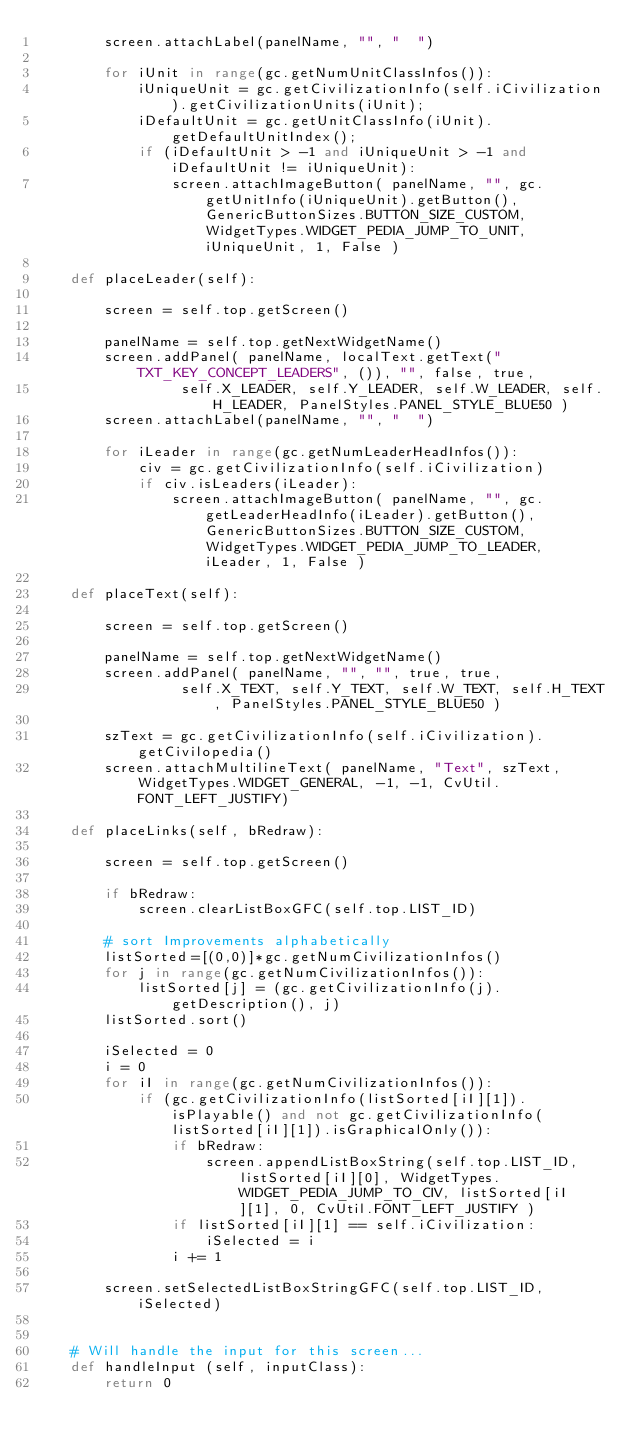Convert code to text. <code><loc_0><loc_0><loc_500><loc_500><_Python_>		screen.attachLabel(panelName, "", "  ")
					
		for iUnit in range(gc.getNumUnitClassInfos()):
			iUniqueUnit = gc.getCivilizationInfo(self.iCivilization).getCivilizationUnits(iUnit);
			iDefaultUnit = gc.getUnitClassInfo(iUnit).getDefaultUnitIndex();
			if (iDefaultUnit > -1 and iUniqueUnit > -1 and iDefaultUnit != iUniqueUnit):
				screen.attachImageButton( panelName, "", gc.getUnitInfo(iUniqueUnit).getButton(), GenericButtonSizes.BUTTON_SIZE_CUSTOM, WidgetTypes.WIDGET_PEDIA_JUMP_TO_UNIT, iUniqueUnit, 1, False )
		
	def placeLeader(self):
		
		screen = self.top.getScreen()
		
		panelName = self.top.getNextWidgetName()
		screen.addPanel( panelName, localText.getText("TXT_KEY_CONCEPT_LEADERS", ()), "", false, true,
				 self.X_LEADER, self.Y_LEADER, self.W_LEADER, self.H_LEADER, PanelStyles.PANEL_STYLE_BLUE50 )
		screen.attachLabel(panelName, "", "  ")

		for iLeader in range(gc.getNumLeaderHeadInfos()):
			civ = gc.getCivilizationInfo(self.iCivilization)
			if civ.isLeaders(iLeader):
				screen.attachImageButton( panelName, "", gc.getLeaderHeadInfo(iLeader).getButton(), GenericButtonSizes.BUTTON_SIZE_CUSTOM, WidgetTypes.WIDGET_PEDIA_JUMP_TO_LEADER, iLeader, 1, False )
		
	def placeText(self):
		
		screen = self.top.getScreen()
		
		panelName = self.top.getNextWidgetName()
		screen.addPanel( panelName, "", "", true, true,
				 self.X_TEXT, self.Y_TEXT, self.W_TEXT, self.H_TEXT, PanelStyles.PANEL_STYLE_BLUE50 )
 
		szText = gc.getCivilizationInfo(self.iCivilization).getCivilopedia()
		screen.attachMultilineText( panelName, "Text", szText, WidgetTypes.WIDGET_GENERAL, -1, -1, CvUtil.FONT_LEFT_JUSTIFY)
													
	def placeLinks(self, bRedraw):

		screen = self.top.getScreen()

		if bRedraw:	
			screen.clearListBoxGFC(self.top.LIST_ID)
		
		# sort Improvements alphabetically
		listSorted=[(0,0)]*gc.getNumCivilizationInfos()
		for j in range(gc.getNumCivilizationInfos()):
			listSorted[j] = (gc.getCivilizationInfo(j).getDescription(), j)
		listSorted.sort()	
			
		iSelected = 0
		i = 0
		for iI in range(gc.getNumCivilizationInfos()):
			if (gc.getCivilizationInfo(listSorted[iI][1]).isPlayable() and not gc.getCivilizationInfo(listSorted[iI][1]).isGraphicalOnly()):
				if bRedraw:
					screen.appendListBoxString(self.top.LIST_ID, listSorted[iI][0], WidgetTypes.WIDGET_PEDIA_JUMP_TO_CIV, listSorted[iI][1], 0, CvUtil.FONT_LEFT_JUSTIFY )
				if listSorted[iI][1] == self.iCivilization:
					iSelected = i
				i += 1
					
		screen.setSelectedListBoxStringGFC(self.top.LIST_ID, iSelected)
			

	# Will handle the input for this screen...
	def handleInput (self, inputClass):
		return 0


</code> 